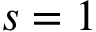<formula> <loc_0><loc_0><loc_500><loc_500>s = 1</formula> 